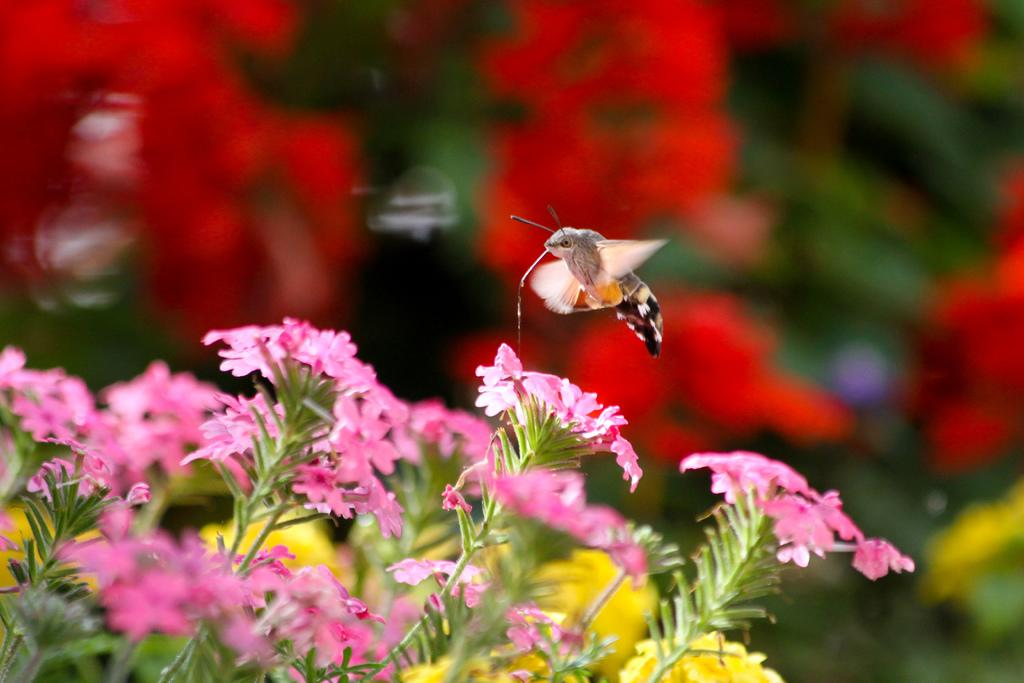What color are the flowers in the image? The flowers in the image are pink. Where are the flowers located? The flowers are on plants. What other creature can be seen in the image? There is a butterfly visible on the flowers. What type of design can be seen on the elbow of the person in the image? There is no person present in the image, so there is no elbow or design to observe. 